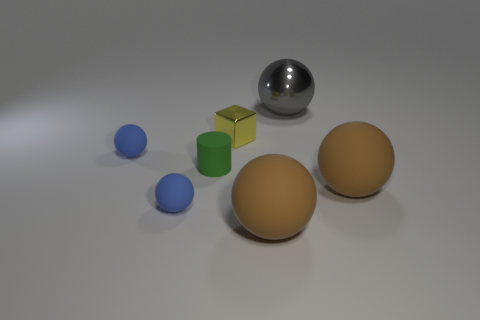Subtract all gray balls. Subtract all gray cylinders. How many balls are left? 4 Subtract all cyan blocks. How many cyan cylinders are left? 0 Add 2 yellows. How many tiny blues exist? 0 Subtract all big brown rubber balls. Subtract all spheres. How many objects are left? 0 Add 4 large objects. How many large objects are left? 7 Add 6 tiny green matte spheres. How many tiny green matte spheres exist? 6 Add 3 rubber cylinders. How many objects exist? 10 Subtract all brown balls. How many balls are left? 3 Subtract all tiny blue spheres. How many spheres are left? 3 Subtract 0 purple cubes. How many objects are left? 7 